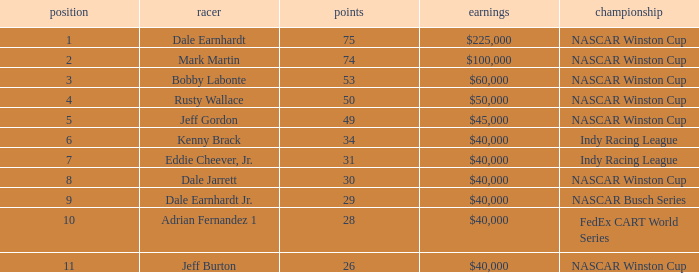What position did the driver earn 31 points? 7.0. 